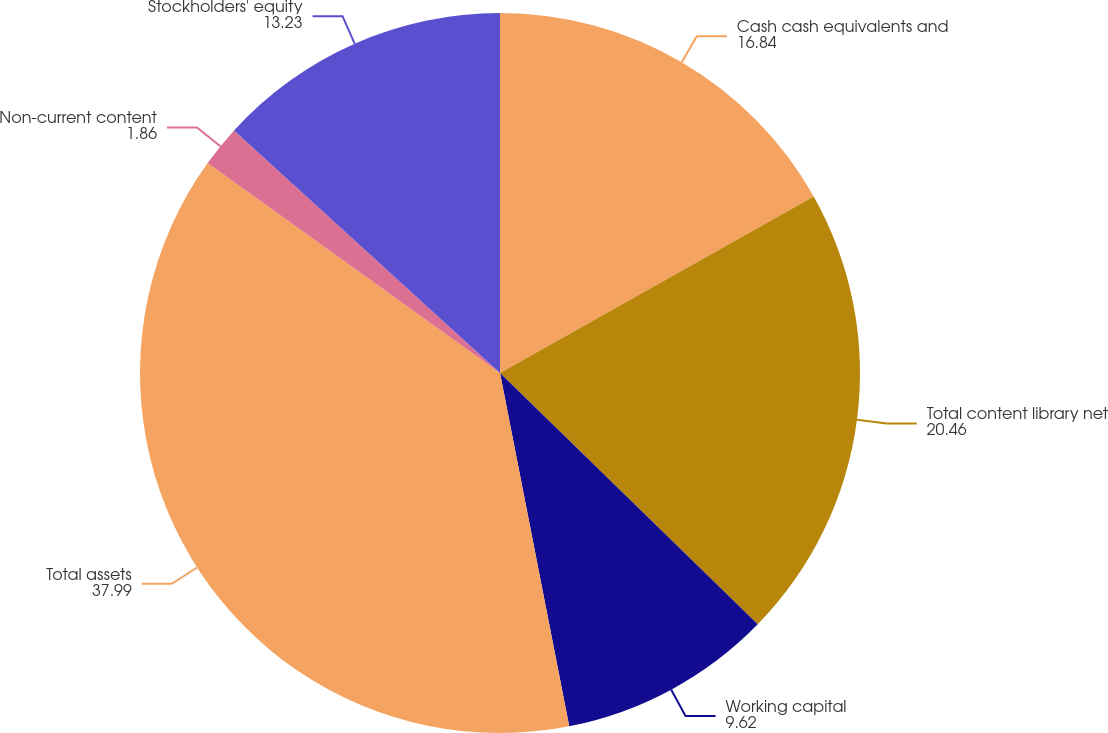<chart> <loc_0><loc_0><loc_500><loc_500><pie_chart><fcel>Cash cash equivalents and<fcel>Total content library net<fcel>Working capital<fcel>Total assets<fcel>Non-current content<fcel>Stockholders' equity<nl><fcel>16.84%<fcel>20.46%<fcel>9.62%<fcel>37.99%<fcel>1.86%<fcel>13.23%<nl></chart> 